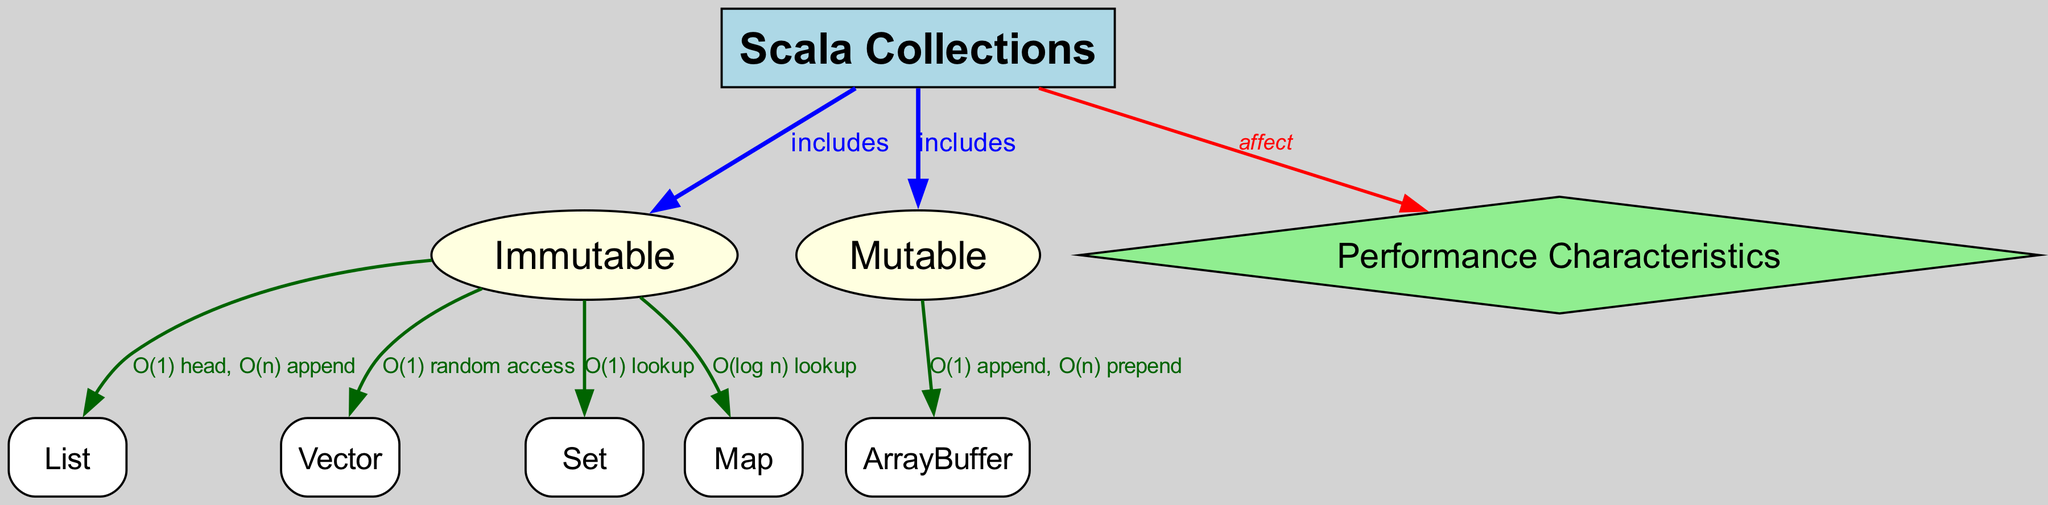What is the main category of Scala Collections? The diagram shows that Scala Collections is divided into two main categories: Immutable and Mutable. This is visually represented as a direct connection from the "Scala Collections" node to both the "Immutable" and "Mutable" nodes.
Answer: Immutable, Mutable Which data structure has O(1) head and O(n) append performance? The diagram indicates that the "List" structure is connected to the "Immutable" category and is labeled with the performance characteristics O(1) head, O(n) append. Thus, this performance metric specifies that the List has these performance characteristics.
Answer: List What is the performance characteristic associated with the "Vector"? According to the diagram, the "Vector" in the Immutable category has a label that states its performance characteristic as O(1) random access. This means that accessing an element from a Vector is performed in constant time.
Answer: O(1) random access How many nodes are there in total in the diagram? By counting the nodes listed in the diagram, there is a total of 9 nodes: Scala Collections, Immutable, Mutable, List, Vector, Set, Map, ArrayBuffer, and Performance Characteristics. This count gives the total node number.
Answer: 9 What is the performance for "ArrayBuffer" in the Mutable category? The diagram shows that the "ArrayBuffer" has performance characteristics of O(1) append and O(n) prepend, indicating efficiency for appending but less efficiency for prepending. This is derived from the labeled connection from "Mutable" to "ArrayBuffer."
Answer: O(1) append, O(n) prepend How does "Scala Collections" affect "Performance Characteristics"? The diagram illustrates that "Scala Collections" has a direct relationship with "Performance Characteristics," which is labeled as "affect." This means the choice of collection type significantly impacts the performance characteristics of operations in Scala.
Answer: affect What type of collection provides O(log n) lookup? The diagram clearly states that the "Map" structure, under the "Immutable" category, possesses a performance characteristic of O(log n) lookup. This indicates how efficient it is to search for elements within this collection type.
Answer: Map What is the relationship between "Immutable" and "Set"? The diagram shows that "Set" is a part of the "Immutable" category as illustrated by the directed edge from "Immutable" to "Set." This indicates that Set is a type of collection included within the Immutable category of Scala Collections.
Answer: includes 